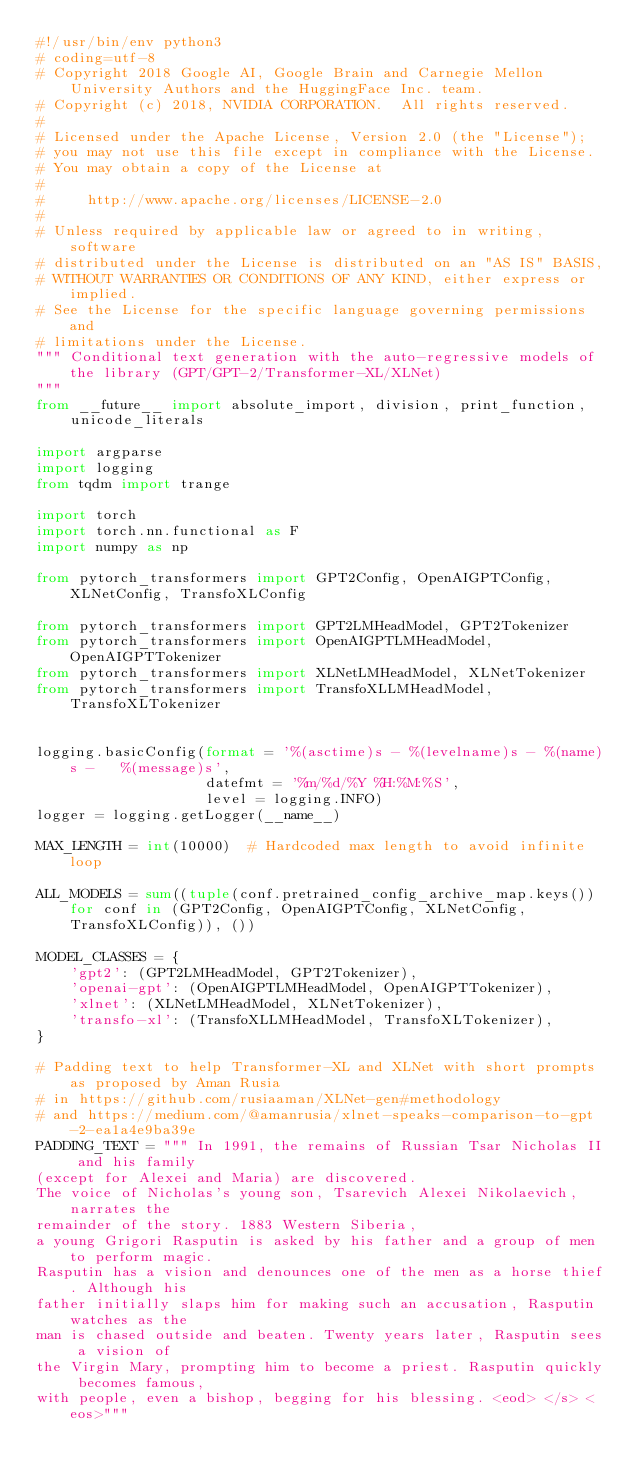<code> <loc_0><loc_0><loc_500><loc_500><_Python_>#!/usr/bin/env python3
# coding=utf-8
# Copyright 2018 Google AI, Google Brain and Carnegie Mellon University Authors and the HuggingFace Inc. team.
# Copyright (c) 2018, NVIDIA CORPORATION.  All rights reserved.
#
# Licensed under the Apache License, Version 2.0 (the "License");
# you may not use this file except in compliance with the License.
# You may obtain a copy of the License at
#
#     http://www.apache.org/licenses/LICENSE-2.0
#
# Unless required by applicable law or agreed to in writing, software
# distributed under the License is distributed on an "AS IS" BASIS,
# WITHOUT WARRANTIES OR CONDITIONS OF ANY KIND, either express or implied.
# See the License for the specific language governing permissions and
# limitations under the License.
""" Conditional text generation with the auto-regressive models of the library (GPT/GPT-2/Transformer-XL/XLNet)
"""
from __future__ import absolute_import, division, print_function, unicode_literals

import argparse
import logging
from tqdm import trange

import torch
import torch.nn.functional as F
import numpy as np

from pytorch_transformers import GPT2Config, OpenAIGPTConfig, XLNetConfig, TransfoXLConfig

from pytorch_transformers import GPT2LMHeadModel, GPT2Tokenizer
from pytorch_transformers import OpenAIGPTLMHeadModel, OpenAIGPTTokenizer
from pytorch_transformers import XLNetLMHeadModel, XLNetTokenizer
from pytorch_transformers import TransfoXLLMHeadModel, TransfoXLTokenizer


logging.basicConfig(format = '%(asctime)s - %(levelname)s - %(name)s -   %(message)s',
                    datefmt = '%m/%d/%Y %H:%M:%S',
                    level = logging.INFO)
logger = logging.getLogger(__name__)

MAX_LENGTH = int(10000)  # Hardcoded max length to avoid infinite loop

ALL_MODELS = sum((tuple(conf.pretrained_config_archive_map.keys()) for conf in (GPT2Config, OpenAIGPTConfig, XLNetConfig, TransfoXLConfig)), ())

MODEL_CLASSES = {
    'gpt2': (GPT2LMHeadModel, GPT2Tokenizer),
    'openai-gpt': (OpenAIGPTLMHeadModel, OpenAIGPTTokenizer),
    'xlnet': (XLNetLMHeadModel, XLNetTokenizer),
    'transfo-xl': (TransfoXLLMHeadModel, TransfoXLTokenizer),
}

# Padding text to help Transformer-XL and XLNet with short prompts as proposed by Aman Rusia
# in https://github.com/rusiaaman/XLNet-gen#methodology
# and https://medium.com/@amanrusia/xlnet-speaks-comparison-to-gpt-2-ea1a4e9ba39e
PADDING_TEXT = """ In 1991, the remains of Russian Tsar Nicholas II and his family
(except for Alexei and Maria) are discovered.
The voice of Nicholas's young son, Tsarevich Alexei Nikolaevich, narrates the
remainder of the story. 1883 Western Siberia,
a young Grigori Rasputin is asked by his father and a group of men to perform magic.
Rasputin has a vision and denounces one of the men as a horse thief. Although his
father initially slaps him for making such an accusation, Rasputin watches as the
man is chased outside and beaten. Twenty years later, Rasputin sees a vision of
the Virgin Mary, prompting him to become a priest. Rasputin quickly becomes famous,
with people, even a bishop, begging for his blessing. <eod> </s> <eos>"""

</code> 